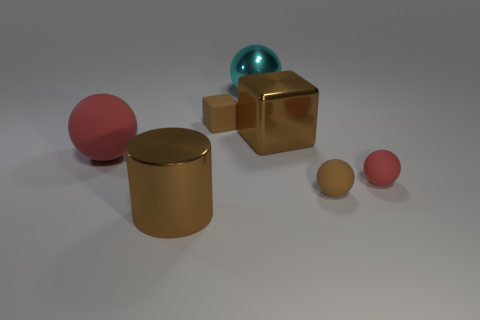Add 1 brown things. How many objects exist? 8 Subtract all balls. How many objects are left? 3 Subtract all big brown blocks. Subtract all big things. How many objects are left? 2 Add 4 tiny brown blocks. How many tiny brown blocks are left? 5 Add 4 purple cubes. How many purple cubes exist? 4 Subtract 0 gray blocks. How many objects are left? 7 